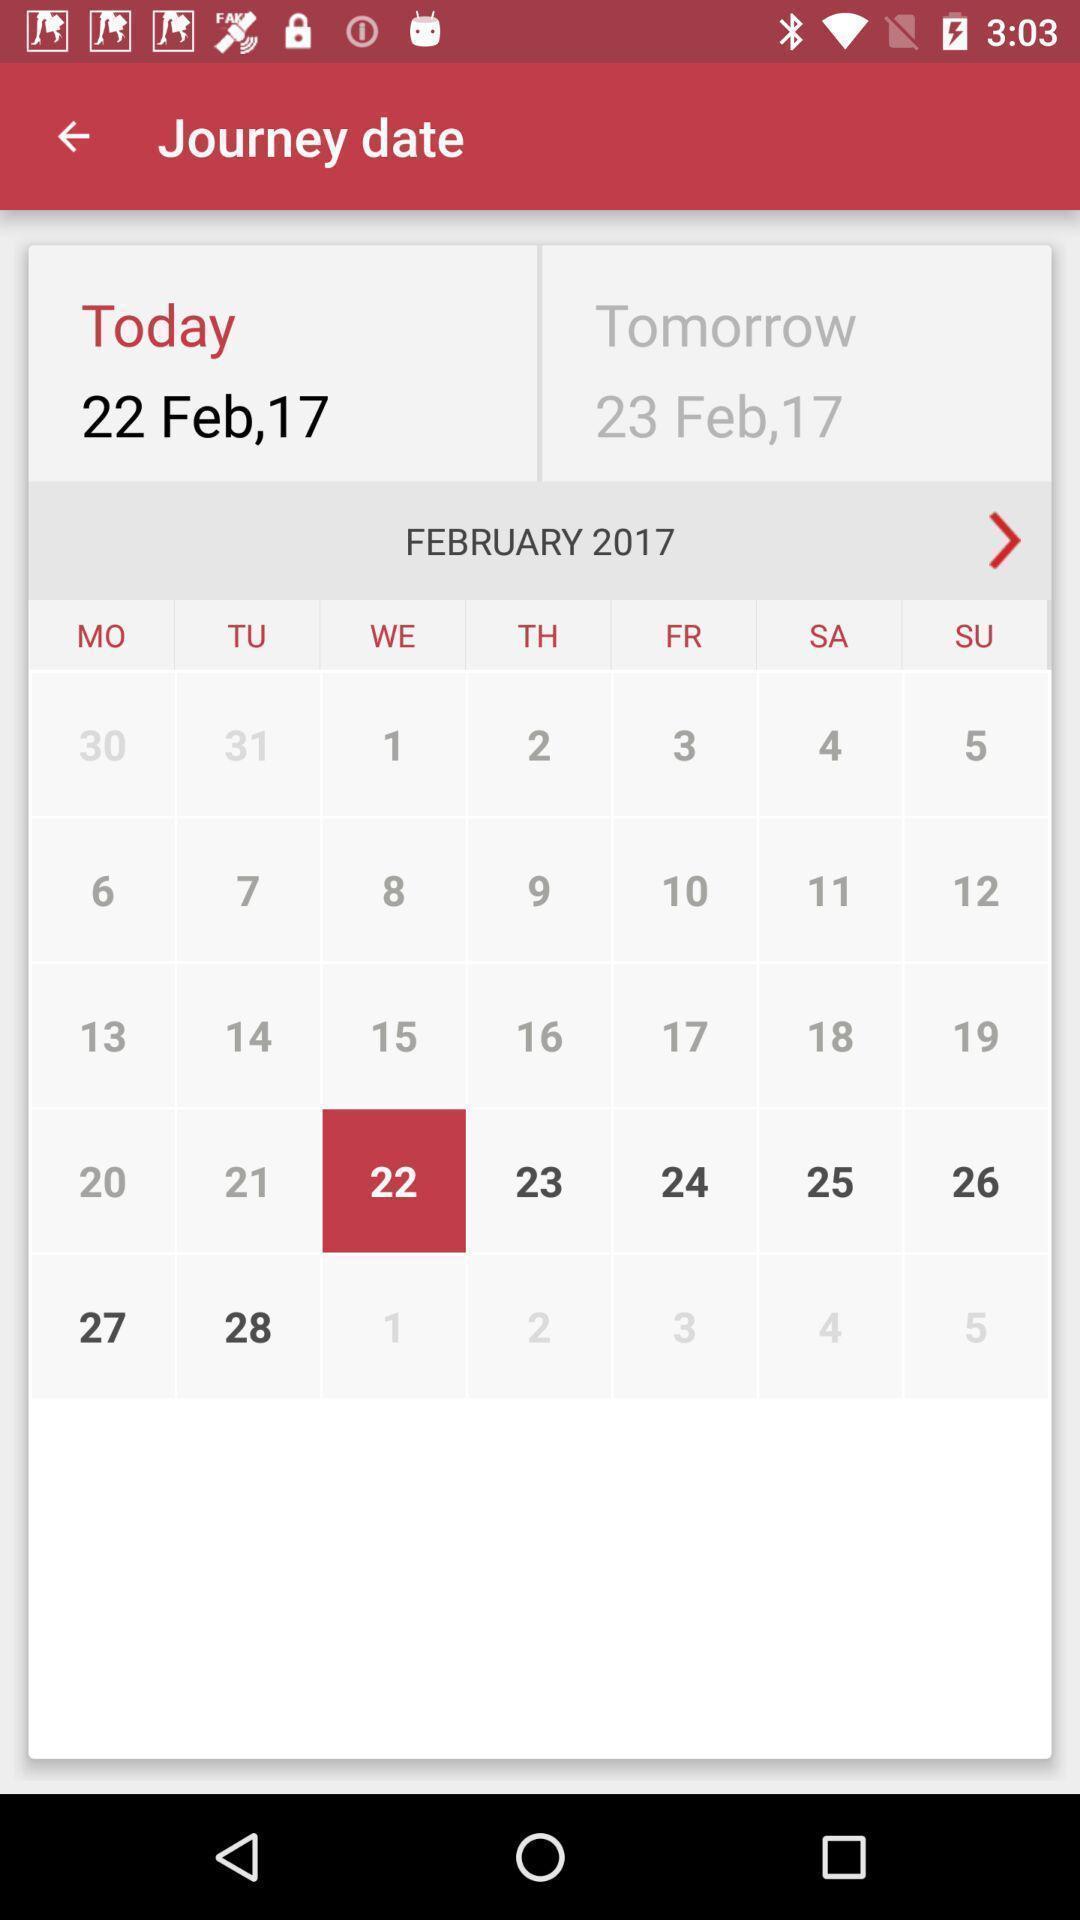Describe this image in words. Screen displaying the calendar showing the journey date. 